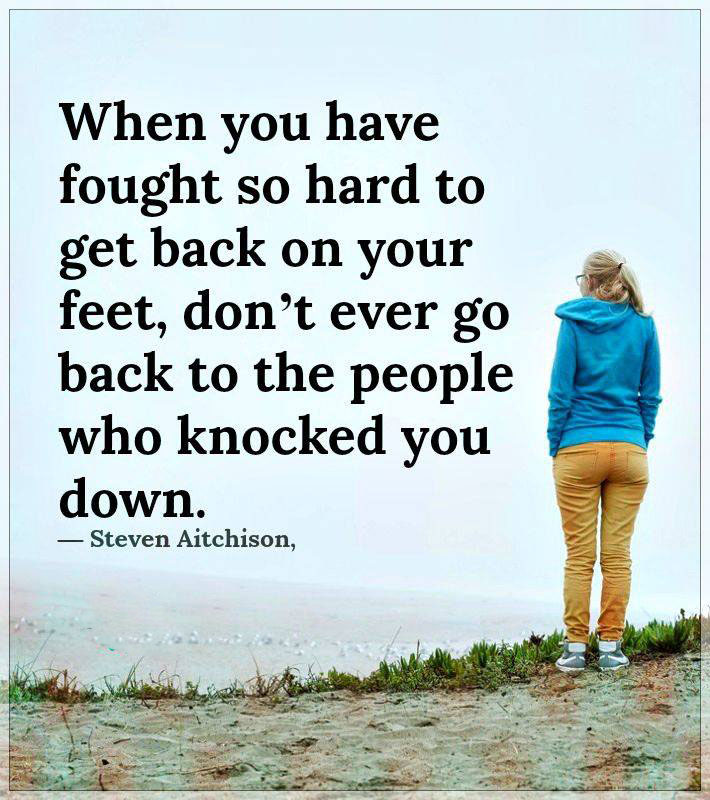Imagine a short story inspired by this scene. A woman stood alone on the foggy coastline, her hoodie pulled tight against the chill in the air. She had walked miles to this spot, a place that held memories of both joy and sorrow. As she stared out into the mist, she couldn't help but recall the words of Steven Aitchison, 'When you have fought so hard to get back on your feet, don’t ever go back to the people who knocked you down.' It was here she decided to start anew, free from the weights of the past, embracing the promise of the horizon before her. What might she see and hear in this setting? Amidst the mist and overcast sky, she might see the faint outline of waves crashing gently against the shore and the silhouettes of distant seabirds gliding silently. The sounds around her could include the rhythmic lapping of the waves, the distant calls of the seabirds, and the whispering winds rustling through the grass and her clothing. Complete serenity enveloped the scene, broken only by nature's subtle symphony. Create a poem inspired by this image. In whispered dawn where sea meets sky,
A lone figure stands as time drifts by.
Hoodie wrapped in twilight’s embrace,
Seeking solace in this empty space.
The world seems still, yet thoughts run free,
In misty haze by the endless sea.
With each breath, she sheds the past,
Finding strength and peace at last.  Considering the inspirational quote, what larger message might this image and moment convey to its viewers? The image, complemented by the quote, profoundly conveys resilience and self-empowerment. It sends a clear message that overcoming struggles and recovering from setbacks should be followed by distancing oneself from negativity and those who contribute to it. It's a visual affirmation of the importance of self-worth, healing, and the courage to move forward, leaving behind what no longer serves one's growth and happiness. 